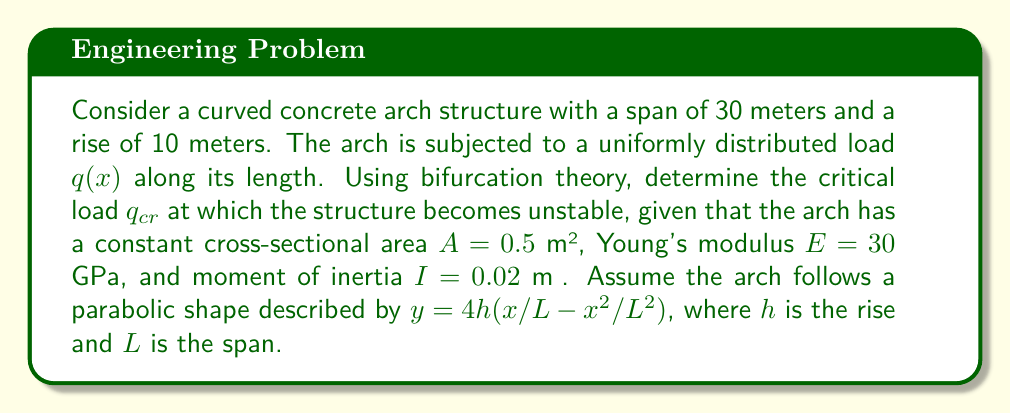Provide a solution to this math problem. To analyze the stability of the curved concrete arch and determine the critical load using bifurcation theory, we'll follow these steps:

1) First, we need to establish the differential equation governing the buckling of the arch. For a curved arch, this is given by:

   $$EI \frac{d^4w}{dx^4} + q(x) \frac{d^2y}{dx^2} = 0$$

   where $w$ is the lateral displacement and $y$ is the arch profile.

2) The arch profile is given by $y = 4h(x/L - x²/L²)$. We need to calculate $\frac{d^2y}{dx^2}$:

   $$\frac{dy}{dx} = 4h(\frac{1}{L} - \frac{2x}{L^2})$$
   $$\frac{d^2y}{dx^2} = -\frac{8h}{L^2}$$

3) Substituting this into our differential equation:

   $$EI \frac{d^4w}{dx^4} - q \frac{8h}{L^2} = 0$$

4) The general solution to this equation is of the form:

   $$w = A \sin(\alpha x) + B \cos(\alpha x) + Cx + D$$

   where $\alpha^4 = \frac{8qh}{EIL^2}$

5) The critical load occurs when the smallest eigenvalue of this problem equals zero. This happens when:

   $$\alpha L = \pi$$

6) Substituting this condition:

   $$(\frac{\pi}{L})^4 = \frac{8q_{cr}h}{EIL^2}$$

7) Solving for $q_{cr}$:

   $$q_{cr} = \frac{\pi^4 EI}{8hL^2}$$

8) Now we can substitute the given values:
   $E = 30 \times 10^9$ Pa
   $I = 0.02$ m⁴
   $h = 10$ m
   $L = 30$ m

   $$q_{cr} = \frac{\pi^4 \times 30 \times 10^9 \times 0.02}{8 \times 10 \times 30^2} = 1,027,751.56 \text{ N/m}$$

9) Converting to kN/m:

   $$q_{cr} \approx 1,027.75 \text{ kN/m}$$

This is the critical load at which the arch becomes unstable.
Answer: $q_{cr} \approx 1,027.75 \text{ kN/m}$ 